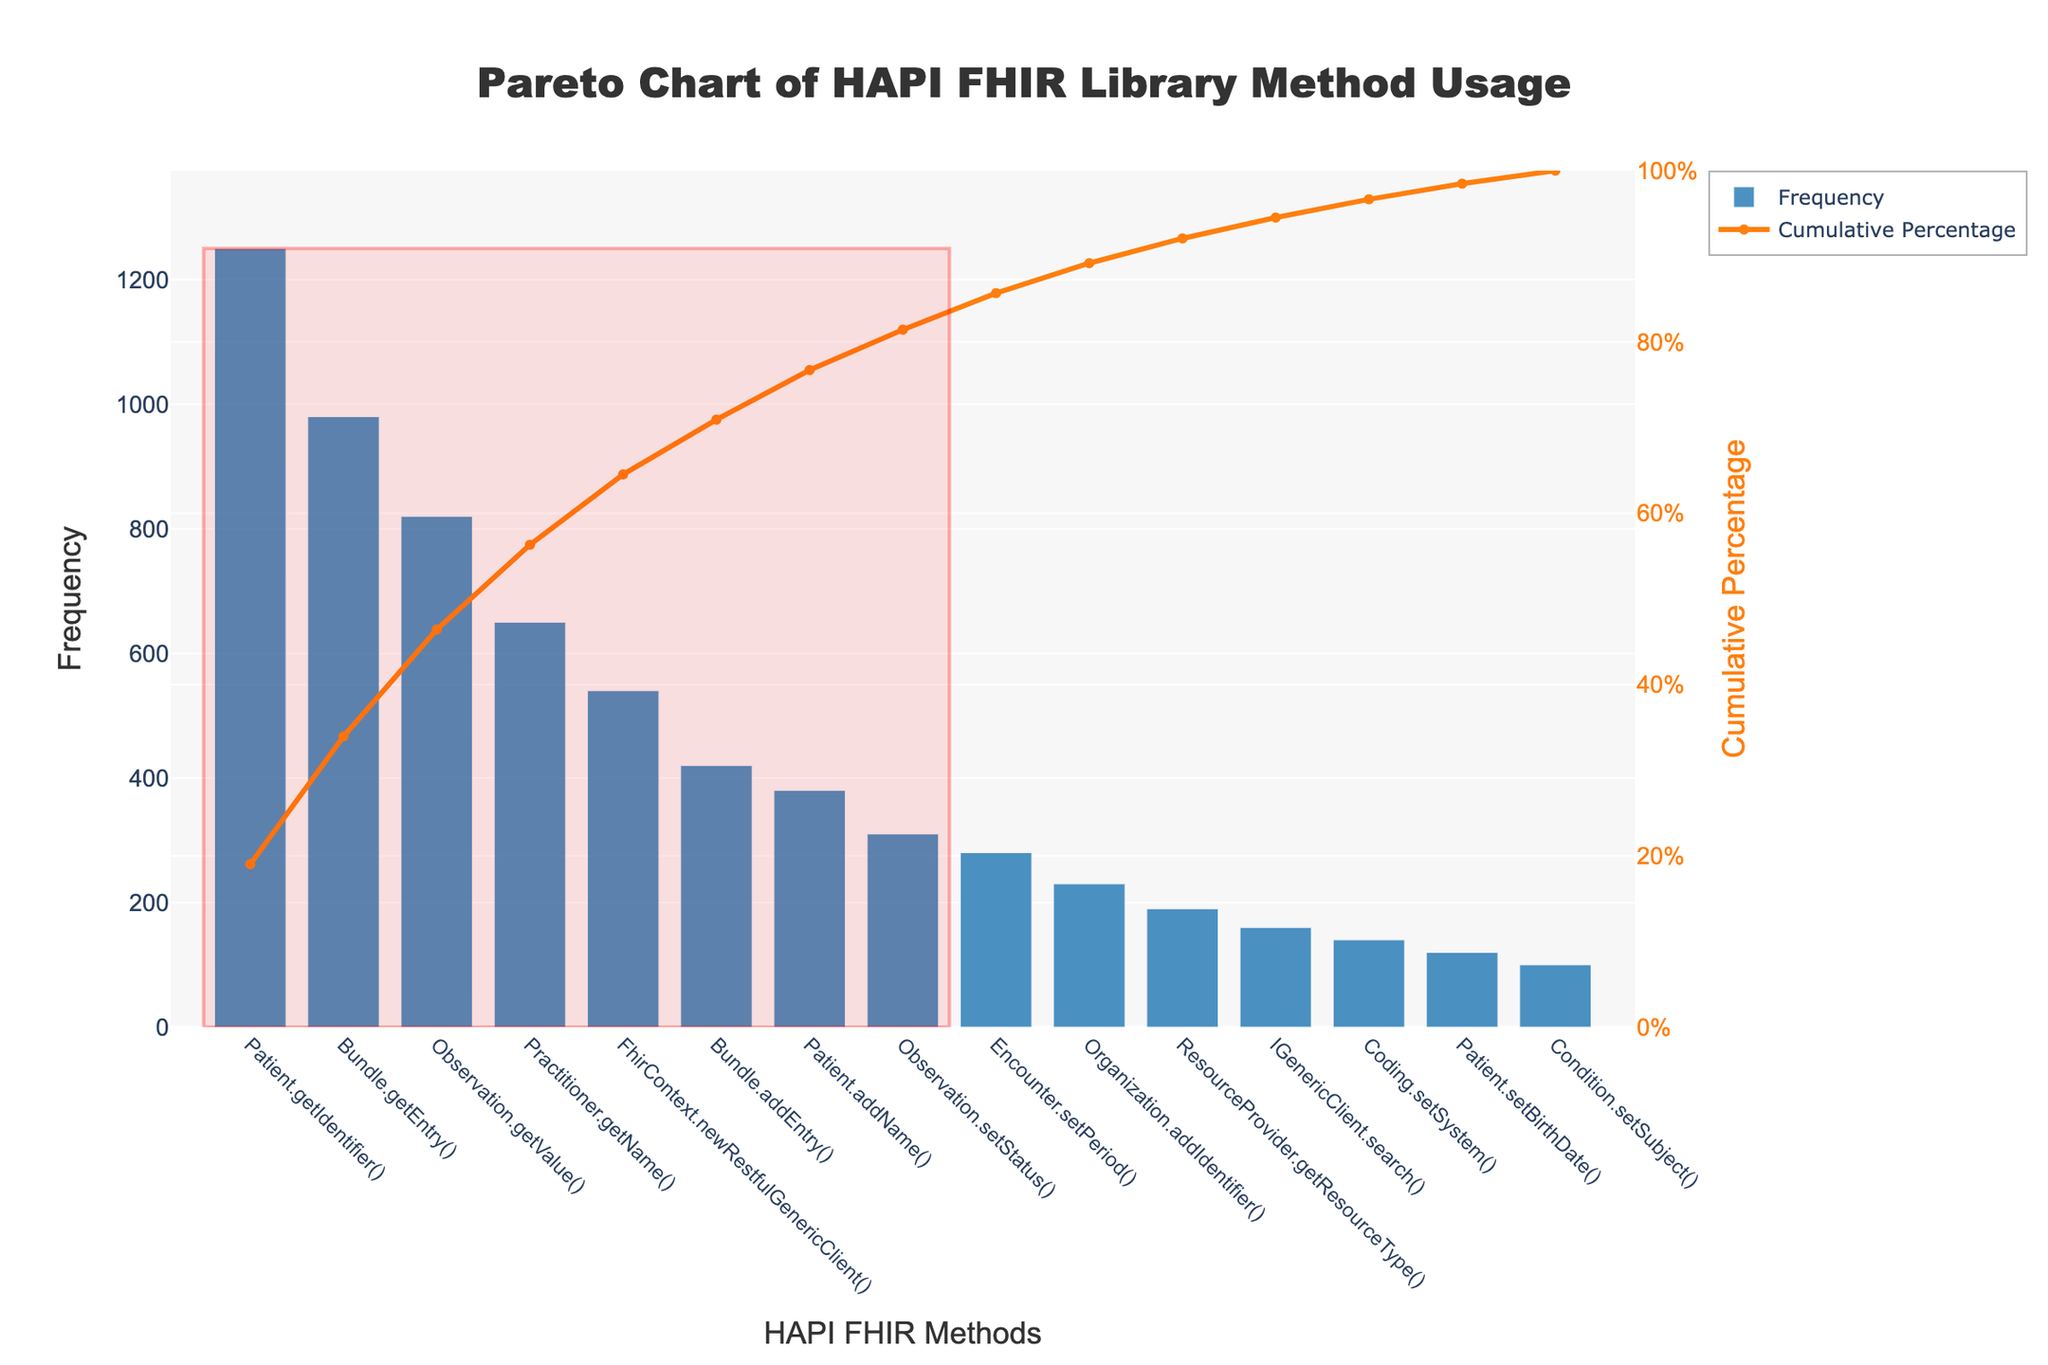What is the title of the chart? The title of the chart is typically located at the top of the figure. It gives a brief summary of the chart content. In this case, the title is 'Pareto Chart of HAPI FHIR Library Method Usage'.
Answer: Pareto Chart of HAPI FHIR Library Method Usage What do the bars represent in this chart? The bars represent the frequency of usage for each HAPI FHIR library method. The x-axis shows the method names, and the y-axis shows their corresponding usage frequency.
Answer: Frequency of method usage Which method is used the most according to the chart? By looking at the tallest bar on the chart, we can identify that 'Patient.getIdentifier()' has the highest bar, indicating it is the most frequently used method.
Answer: Patient.getIdentifier() How many methods contribute to 80% of the total usage? The cumulative percentage line helps in identifying the number of methods that contribute to 80% of the total usage. The rectangle highlights these methods. By counting from 'Patient.getIdentifier()' until the edge of the rectangle, we see that there are six methods.
Answer: Six methods What is the cumulative percentage of the 'Observation.setStatus()' method? Locate the method 'Observation.setStatus()' on the x-axis, and then trace upward to the cumulative percentage line. By reading the value on the right y-axis, we can determine the cumulative percentage, which is around 90%.
Answer: 90% Which method has a frequency closest to 500? By looking at the y-axis values and cross-referencing with the length of the bars, we can see that 'FhirContext.newRestfulGenericClient()' has a frequency of 540, which is closest to 500.
Answer: FhirContext.newRestfulGenericClient() What is the range for the cumulative percentage y-axis? The cumulative percentage y-axis is on the right side of the chart. By examining the axis, we can see it starts from 0% and goes up to 100%.
Answer: 0% to 100% How many methods have a usage frequency greater than 500? By counting the number of bars that extend beyond the 500 mark on the primary y-axis, we find that there are four methods with a frequency greater than 500.
Answer: Four methods What visual element is used to highlight the most important methods? The most important methods are highlighted by a rectangle. This rectangle includes the bars contributing to 80% of the total usage.
Answer: A rectangle What color is used to represent the frequency of method usage in the bars? The bars representing the frequency of method usage are colored in a shade of blue.
Answer: Blue 